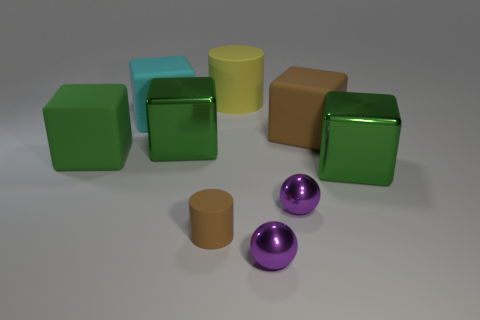Subtract all brown balls. How many green blocks are left? 3 Subtract all brown blocks. How many blocks are left? 4 Subtract all green matte cubes. How many cubes are left? 4 Subtract all blue cubes. Subtract all red cylinders. How many cubes are left? 5 Subtract all blocks. How many objects are left? 4 Subtract 0 green balls. How many objects are left? 9 Subtract all green cylinders. Subtract all tiny matte cylinders. How many objects are left? 8 Add 8 cyan blocks. How many cyan blocks are left? 9 Add 3 yellow matte cylinders. How many yellow matte cylinders exist? 4 